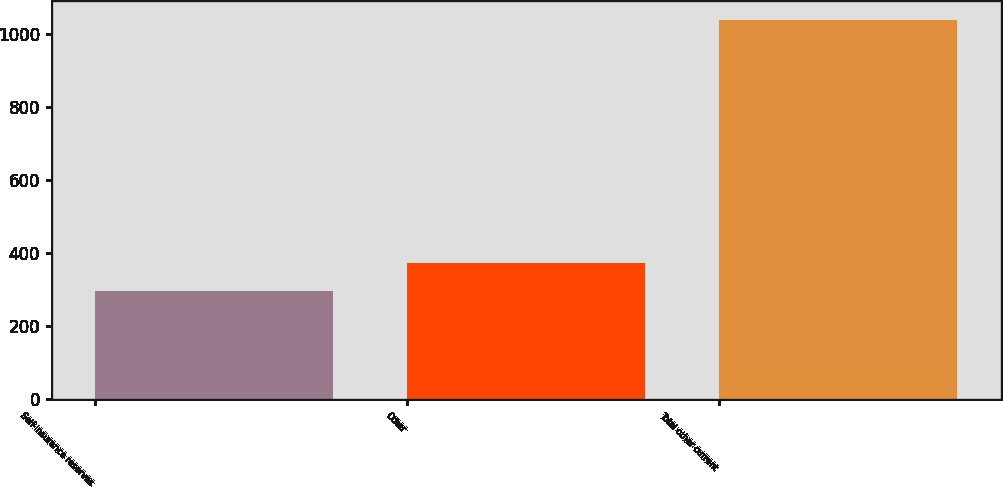<chart> <loc_0><loc_0><loc_500><loc_500><bar_chart><fcel>Self-insurance reserves<fcel>Other<fcel>Total other current<nl><fcel>298<fcel>372.2<fcel>1040<nl></chart> 